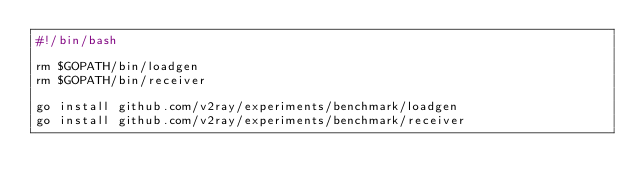<code> <loc_0><loc_0><loc_500><loc_500><_Bash_>#!/bin/bash

rm $GOPATH/bin/loadgen
rm $GOPATH/bin/receiver

go install github.com/v2ray/experiments/benchmark/loadgen
go install github.com/v2ray/experiments/benchmark/receiver
</code> 